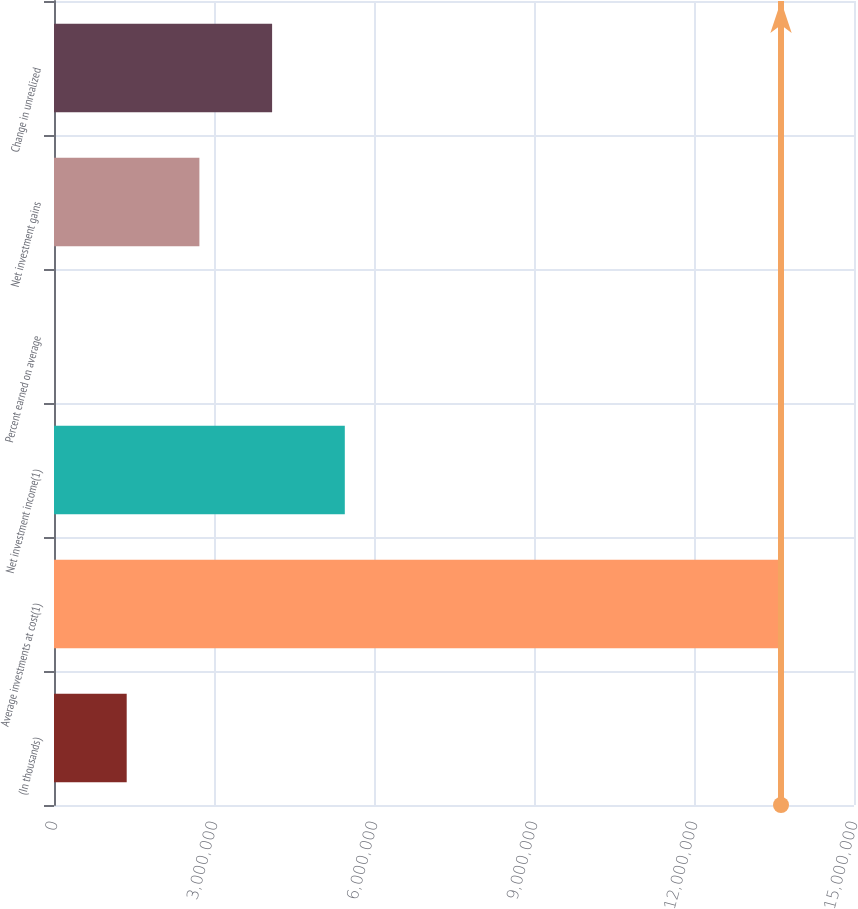<chart> <loc_0><loc_0><loc_500><loc_500><bar_chart><fcel>(In thousands)<fcel>Average investments at cost(1)<fcel>Net investment income(1)<fcel>Percent earned on average<fcel>Net investment gains<fcel>Change in unrealized<nl><fcel>1.36316e+06<fcel>1.36316e+07<fcel>5.45262e+06<fcel>3.9<fcel>2.72631e+06<fcel>4.08947e+06<nl></chart> 